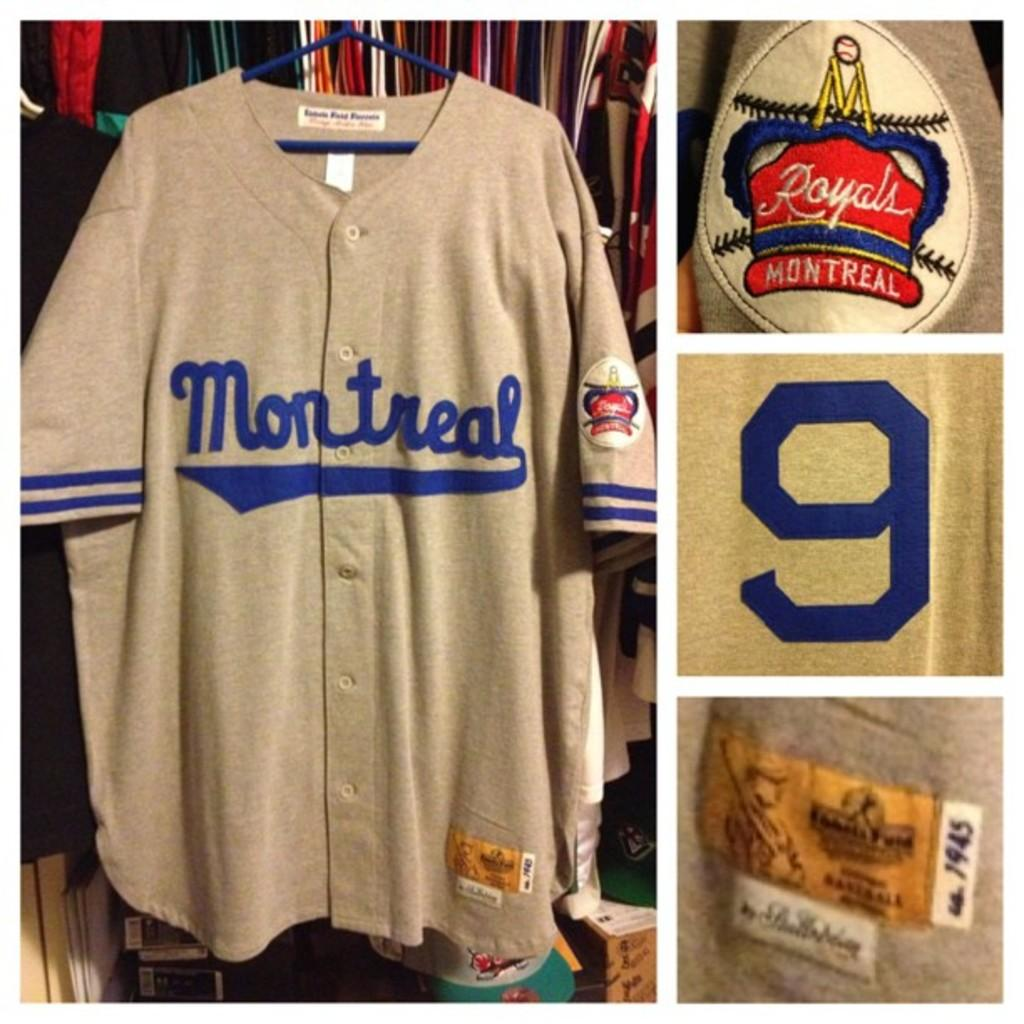<image>
Present a compact description of the photo's key features. A picture of an off white shirt with Montreal written on it in blue. 